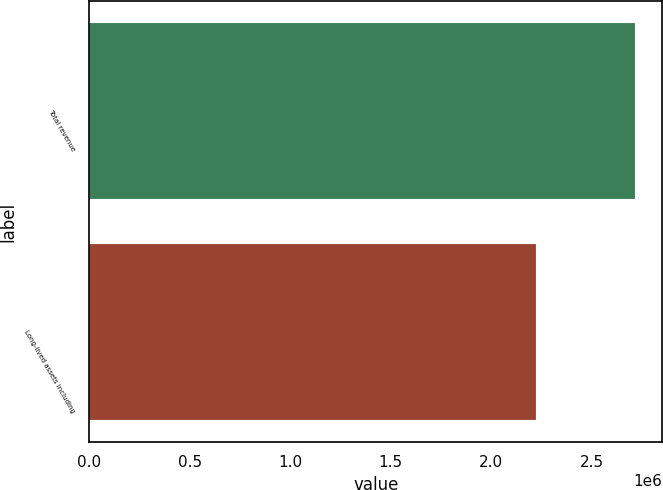<chart> <loc_0><loc_0><loc_500><loc_500><bar_chart><fcel>Total revenue<fcel>Long-lived assets including<nl><fcel>2.71522e+06<fcel>2.22129e+06<nl></chart> 